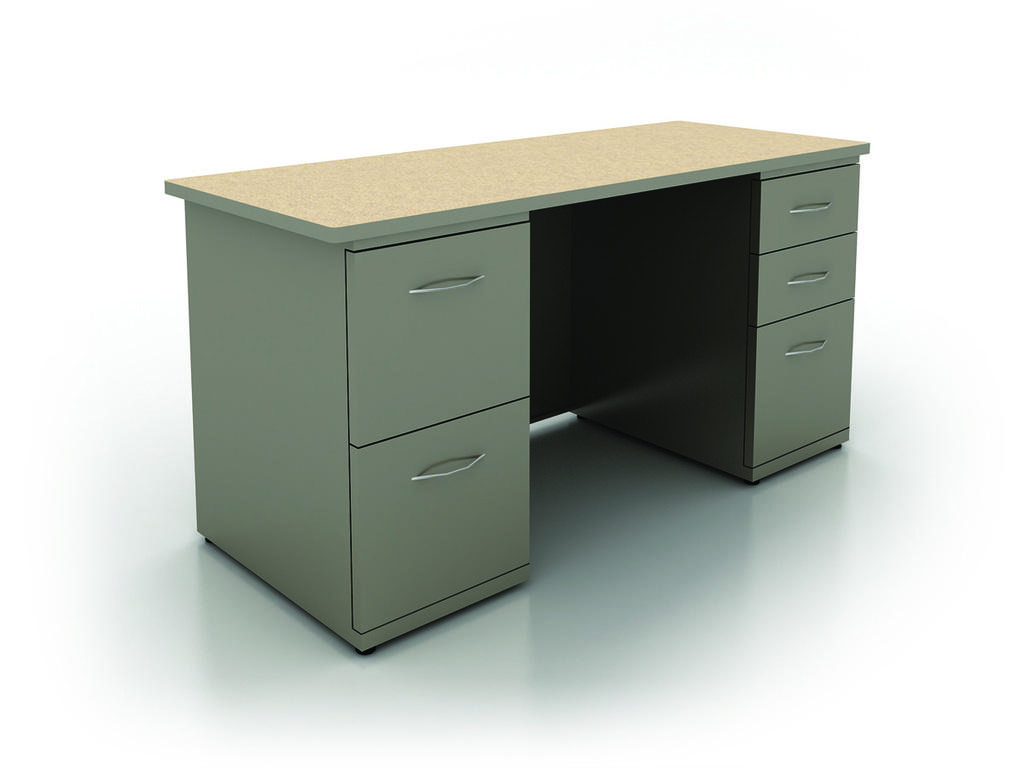What type of furniture is present in the image? There is a table in the image. What is the color of the surface the table is on? The table is on a white surface. What can be observed about the background of the image? The background of the image is white. Where is the drawer located in the image? There is no drawer present in the image. What type of bit is being used to create the white background in the image? The image does not show any tools or methods used to create the white background. 